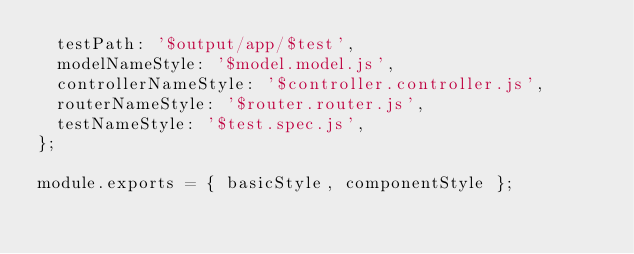<code> <loc_0><loc_0><loc_500><loc_500><_JavaScript_>  testPath: '$output/app/$test',
  modelNameStyle: '$model.model.js',
  controllerNameStyle: '$controller.controller.js',
  routerNameStyle: '$router.router.js',
  testNameStyle: '$test.spec.js',
};

module.exports = { basicStyle, componentStyle };
</code> 